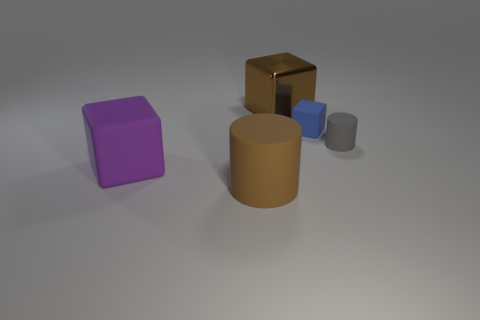There is a rubber cylinder that is in front of the big purple rubber cube; how big is it?
Provide a succinct answer. Large. There is a cylinder that is in front of the large purple thing; what is it made of?
Ensure brevity in your answer.  Rubber. What number of blue things are big rubber cylinders or tiny matte things?
Provide a succinct answer. 1. Are the tiny gray object and the brown object that is behind the purple rubber object made of the same material?
Your answer should be very brief. No. Is the number of big metallic objects in front of the purple block the same as the number of small gray rubber things that are behind the small matte cylinder?
Make the answer very short. Yes. Do the purple matte object and the thing behind the blue thing have the same size?
Provide a succinct answer. Yes. Are there more small cylinders in front of the big purple rubber object than big brown cubes?
Offer a very short reply. No. How many gray cylinders have the same size as the purple cube?
Your answer should be compact. 0. There is a brown thing that is in front of the small matte cylinder; is it the same size as the cube that is behind the tiny rubber cube?
Keep it short and to the point. Yes. Is the number of small blue blocks right of the small gray thing greater than the number of large brown shiny cubes that are behind the tiny rubber block?
Provide a short and direct response. No. 